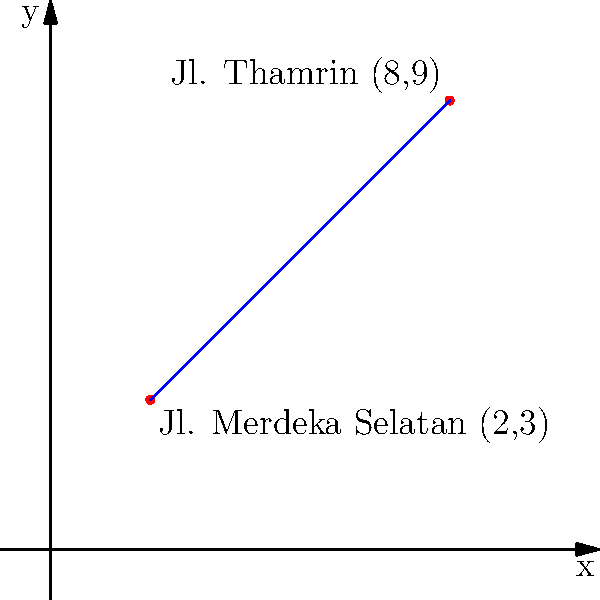Two popular streets in Jakarta's city center, Jl. Merdeka Selatan and Jl. Thamrin, can be represented as points on a coordinate plane. If Jl. Merdeka Selatan is at point (2,3) and Jl. Thamrin is at point (8,9), what is the equation of the line passing through these two points? To find the equation of a line passing through two points, we can use the point-slope form of a line: $y - y_1 = m(x - x_1)$, where $m$ is the slope of the line.

Step 1: Calculate the slope $m$ using the two given points.
$m = \frac{y_2 - y_1}{x_2 - x_1} = \frac{9 - 3}{8 - 2} = \frac{6}{6} = 1$

Step 2: Use either point and the calculated slope in the point-slope form.
Let's use (2,3) as $(x_1, y_1)$:
$y - 3 = 1(x - 2)$

Step 3: Simplify the equation.
$y - 3 = x - 2$
$y = x - 2 + 3$
$y = x + 1$

Therefore, the equation of the line passing through Jl. Merdeka Selatan (2,3) and Jl. Thamrin (8,9) is $y = x + 1$.
Answer: $y = x + 1$ 